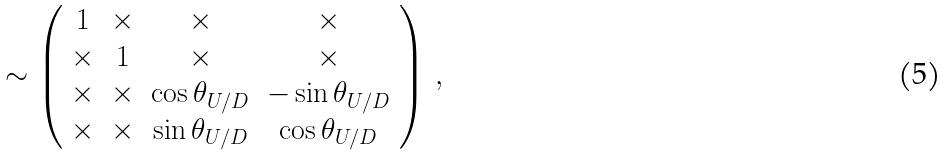<formula> <loc_0><loc_0><loc_500><loc_500>\sim \left ( \begin{array} { c c c c } { 1 } & { \times } & { \times } & { \times } \\ { \times } & { 1 } & { \times } & { \times } \\ { \times } & { \times } & { { \cos \theta _ { U / D } } } & { { - \sin \theta _ { U / D } } } \\ { \times } & { \times } & { { \sin \theta _ { U / D } } } & { { \cos \theta _ { U / D } } } \end{array} \right ) \, ,</formula> 